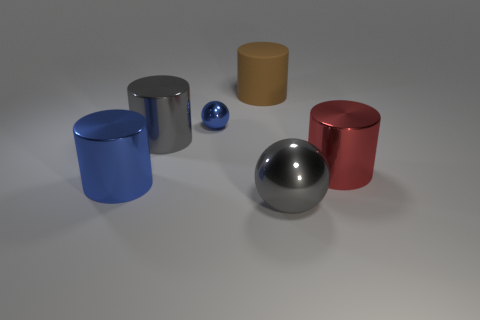Are there any other things that have the same material as the big brown cylinder?
Keep it short and to the point. No. Is the number of small green metal blocks greater than the number of small blue shiny objects?
Offer a terse response. No. Is there a gray thing that has the same size as the red shiny object?
Your answer should be compact. Yes. How many things are things that are in front of the large gray cylinder or big shiny things that are right of the blue metallic sphere?
Make the answer very short. 3. There is a metallic sphere right of the cylinder that is behind the blue metal sphere; what color is it?
Your answer should be very brief. Gray. There is another sphere that is the same material as the blue sphere; what color is it?
Offer a terse response. Gray. How many big metal cylinders are the same color as the small object?
Make the answer very short. 1. How many things are either big blue matte balls or balls?
Your answer should be compact. 2. The blue metal object that is the same size as the gray metallic cylinder is what shape?
Offer a very short reply. Cylinder. How many spheres are in front of the red metal cylinder and behind the gray ball?
Provide a short and direct response. 0. 